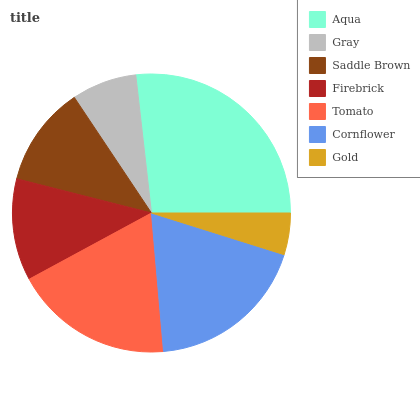Is Gold the minimum?
Answer yes or no. Yes. Is Aqua the maximum?
Answer yes or no. Yes. Is Gray the minimum?
Answer yes or no. No. Is Gray the maximum?
Answer yes or no. No. Is Aqua greater than Gray?
Answer yes or no. Yes. Is Gray less than Aqua?
Answer yes or no. Yes. Is Gray greater than Aqua?
Answer yes or no. No. Is Aqua less than Gray?
Answer yes or no. No. Is Firebrick the high median?
Answer yes or no. Yes. Is Firebrick the low median?
Answer yes or no. Yes. Is Gray the high median?
Answer yes or no. No. Is Saddle Brown the low median?
Answer yes or no. No. 